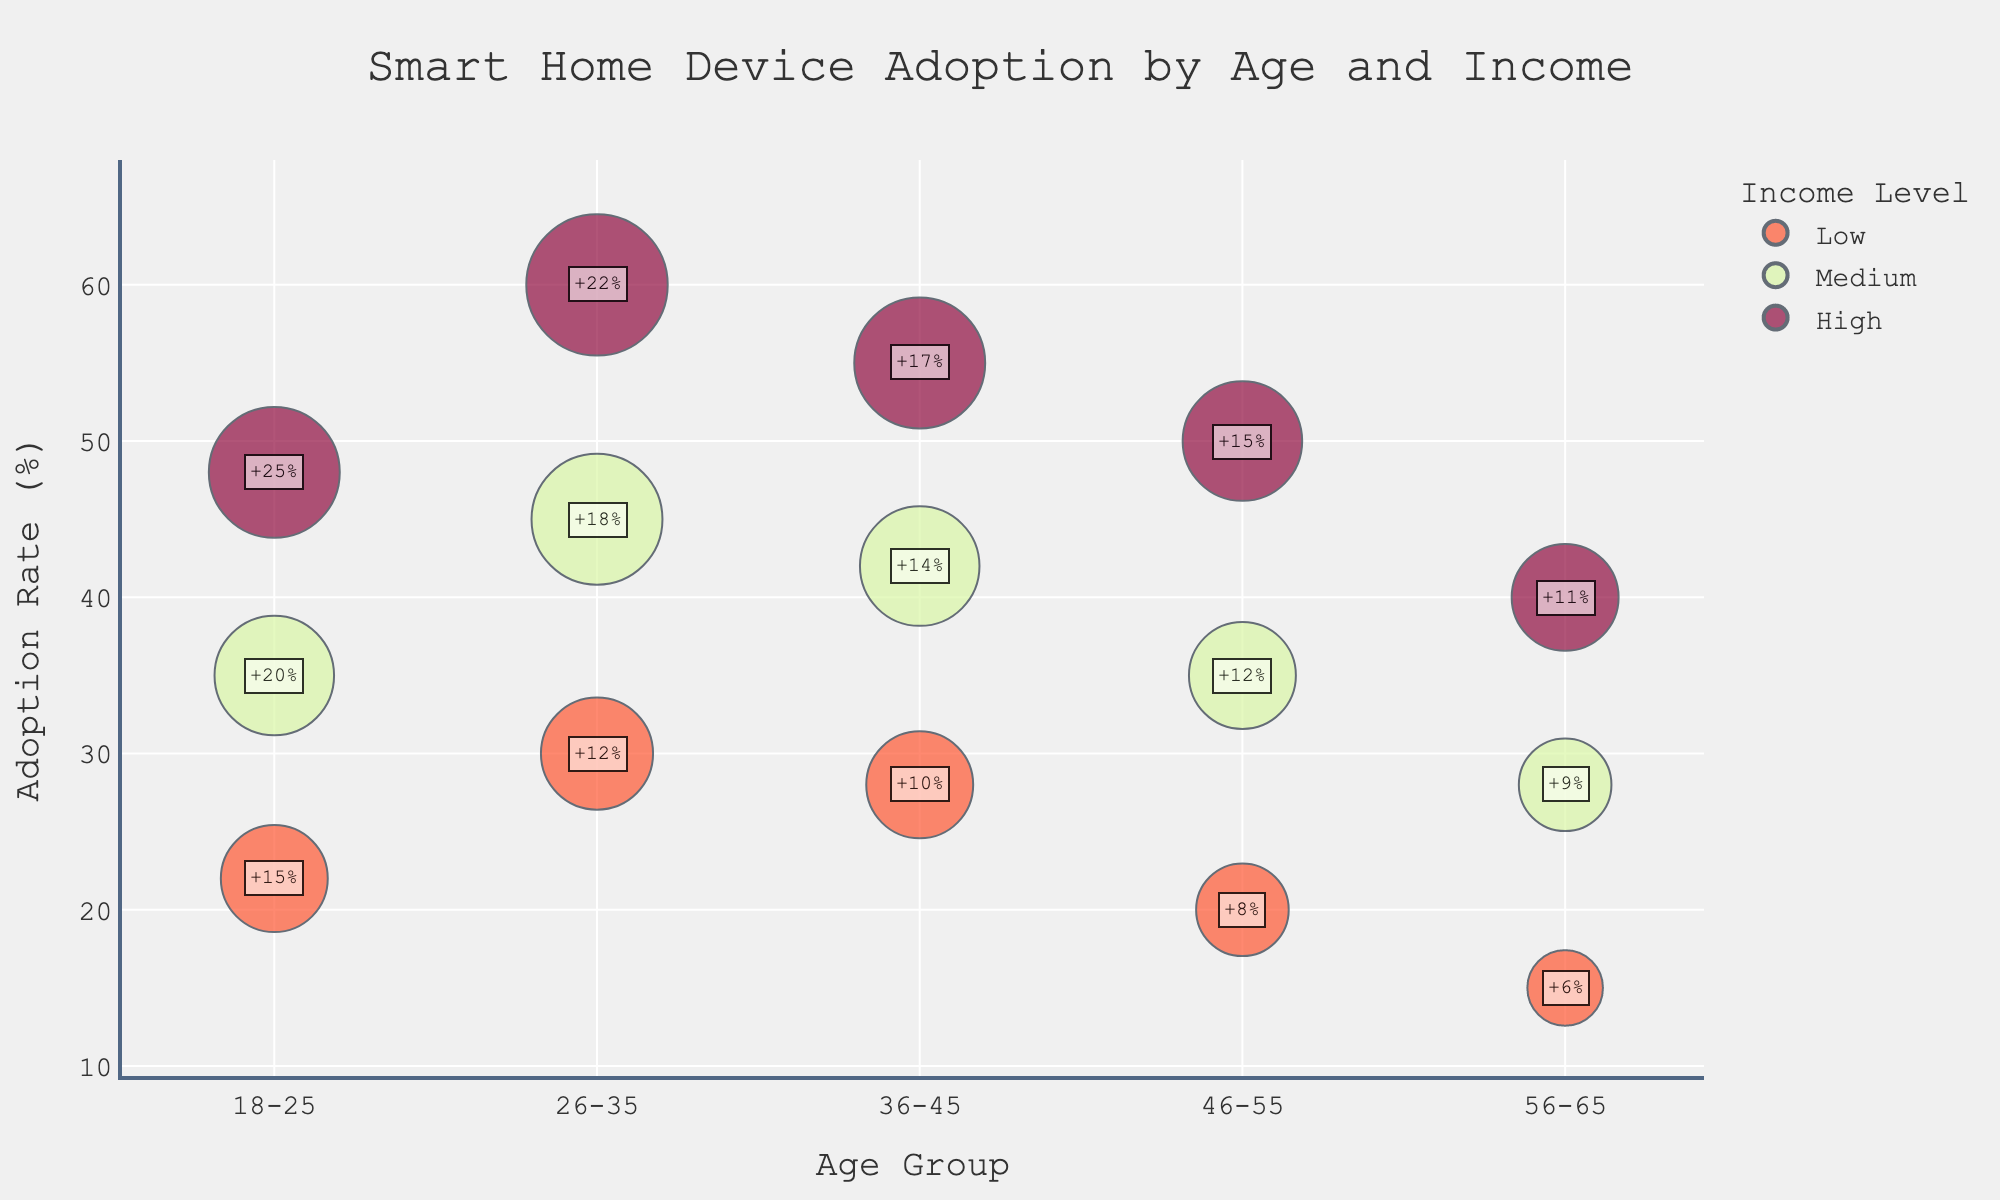Which age group has the highest smart home device adoption rate? Look for the highest point on the y-axis labeled "Smart Home Device Adoption (%)" and identify the corresponding age group on the x-axis.
Answer: 26-35 Which income level has the smallest average number of devices per household in the 46-55 age group? Identify the bubbles for the 46-55 age group, then look for the smallest bubble size, since the bubble size represents the "Average Devices Per Household".
Answer: Low What's the growth in adoption rate for the high-income group aged 26-35? Find the high-income group within the 26-35 age range and look for the annotation next to its bubble indicating the growth rate.
Answer: +22% Compare the smart home device adoption rates between high-income and low-income groups for the age group 36-45. Locate the bubbles for both high-income and low-income groups under the age 36-45 category and compare their y-values. The high-income group's y-value is 55%, and the low-income group's y-value is 28%.
Answer: High-income > Low-income Which age group has the lowest smart home device adoption rate for the medium-income level? Find the medium-income bubbles for all age groups and identify the one with the lowest y-value.
Answer: 56-65 What is the total smart home device adoption rate for high-income groups across all age groups? Summing up the adoption rates for high-income bubbles across all age groups: 48% (18-25) + 60% (26-35) + 55% (36-45) + 50% (46-55) + 40% (56-65).
Answer: 253% What is the average number of devices per household for the medium-income group across all age groups? Calculate the average of the "Average Devices Per Household" values for medium-income groups: (2.5 + 3 + 2.5 + 2 + 1.5) / 5.
Answer: 2.3 What is the difference in growth rates between the low and high-income groups in the 18-25 age range? Subtract the growth rate of the low-income group from the high-income group within the 18-25 age range: 25% (high) - 15% (low).
Answer: 10% 